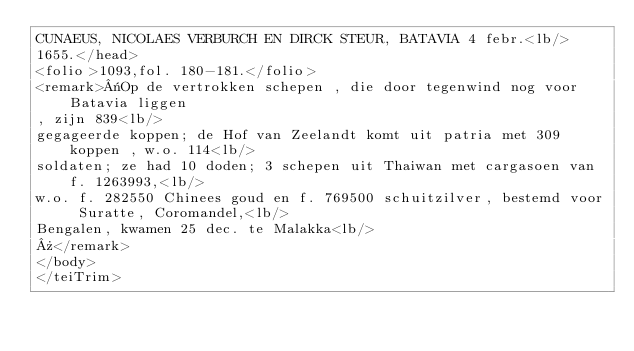<code> <loc_0><loc_0><loc_500><loc_500><_XML_>CUNAEUS, NICOLAES VERBURCH EN DIRCK STEUR, BATAVIA 4 febr.<lb/>
1655.</head>
<folio>1093,fol. 180-181.</folio>
<remark>«Op de vertrokken schepen , die door tegenwind nog voor Batavia liggen
, zijn 839<lb/>
gegageerde koppen; de Hof van Zeelandt komt uit patria met 309 koppen , w.o. 114<lb/>
soldaten; ze had 10 doden; 3 schepen uit Thaiwan met cargasoen van f. 1263993,<lb/>
w.o. f. 282550 Chinees goud en f. 769500 schuitzilver, bestemd voor Suratte, Coromandel,<lb/>
Bengalen, kwamen 25 dec. te Malakka<lb/>
»</remark>
</body>
</teiTrim></code> 